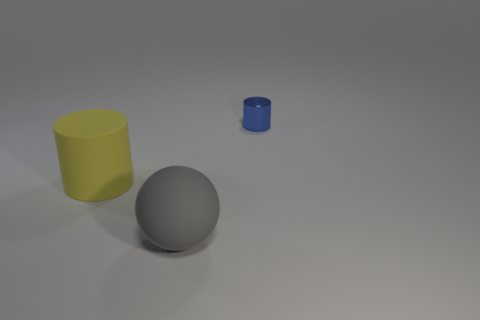Is there another rubber ball that has the same color as the sphere?
Ensure brevity in your answer.  No. How big is the yellow rubber thing?
Offer a very short reply. Large. Do the small cylinder and the big cylinder have the same color?
Keep it short and to the point. No. How many objects are blue cylinders or large gray matte spheres in front of the matte cylinder?
Provide a short and direct response. 2. How many large gray matte balls are in front of the object that is behind the cylinder that is left of the shiny cylinder?
Keep it short and to the point. 1. What number of green shiny things are there?
Keep it short and to the point. 0. There is a thing to the right of the gray thing; is its size the same as the big yellow matte object?
Provide a succinct answer. No. What number of matte things are gray spheres or yellow objects?
Your answer should be compact. 2. There is a cylinder that is in front of the small shiny thing; what number of yellow matte cylinders are in front of it?
Offer a very short reply. 0. What is the shape of the object that is both to the right of the yellow matte object and on the left side of the blue object?
Make the answer very short. Sphere. 